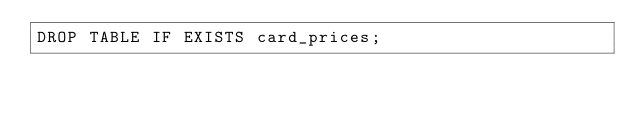<code> <loc_0><loc_0><loc_500><loc_500><_SQL_>DROP TABLE IF EXISTS card_prices;
</code> 